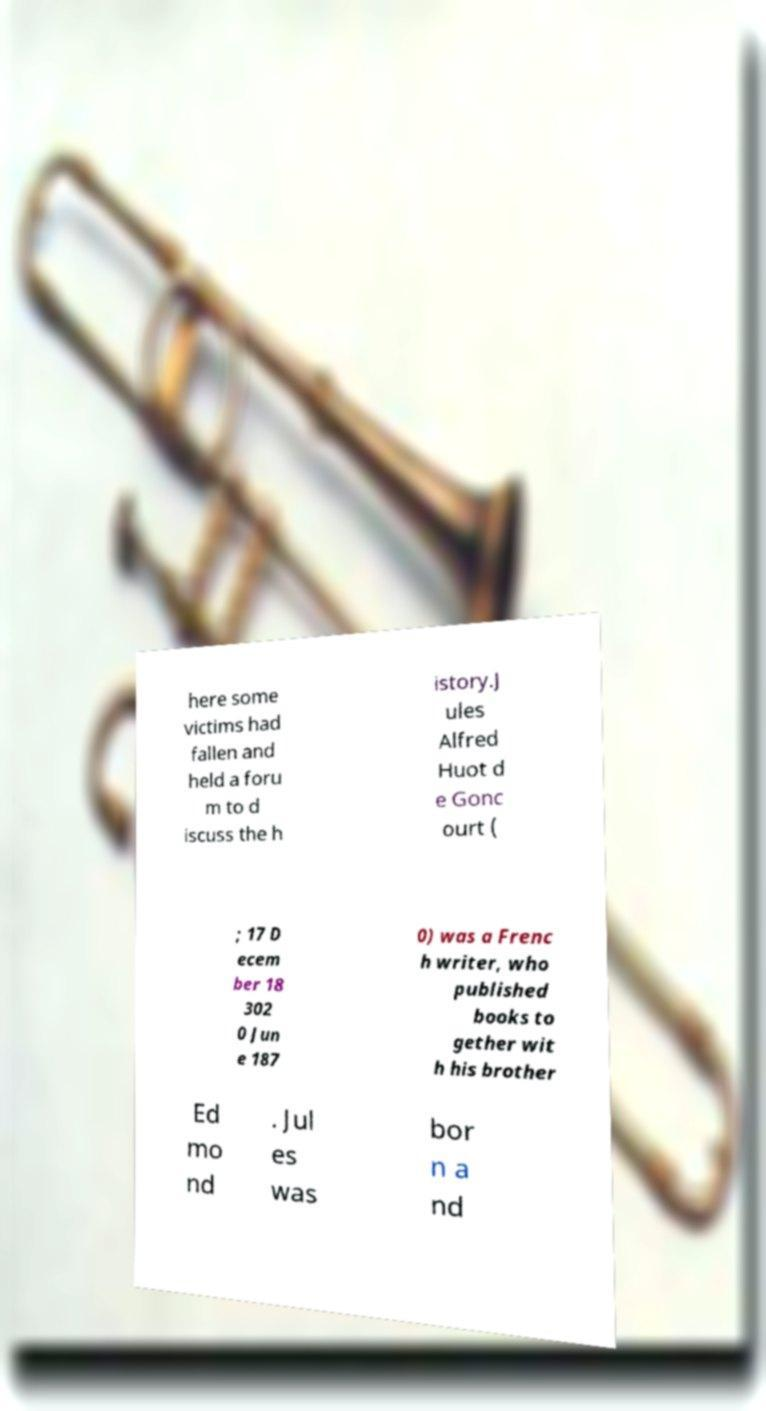What messages or text are displayed in this image? I need them in a readable, typed format. here some victims had fallen and held a foru m to d iscuss the h istory.J ules Alfred Huot d e Gonc ourt ( ; 17 D ecem ber 18 302 0 Jun e 187 0) was a Frenc h writer, who published books to gether wit h his brother Ed mo nd . Jul es was bor n a nd 